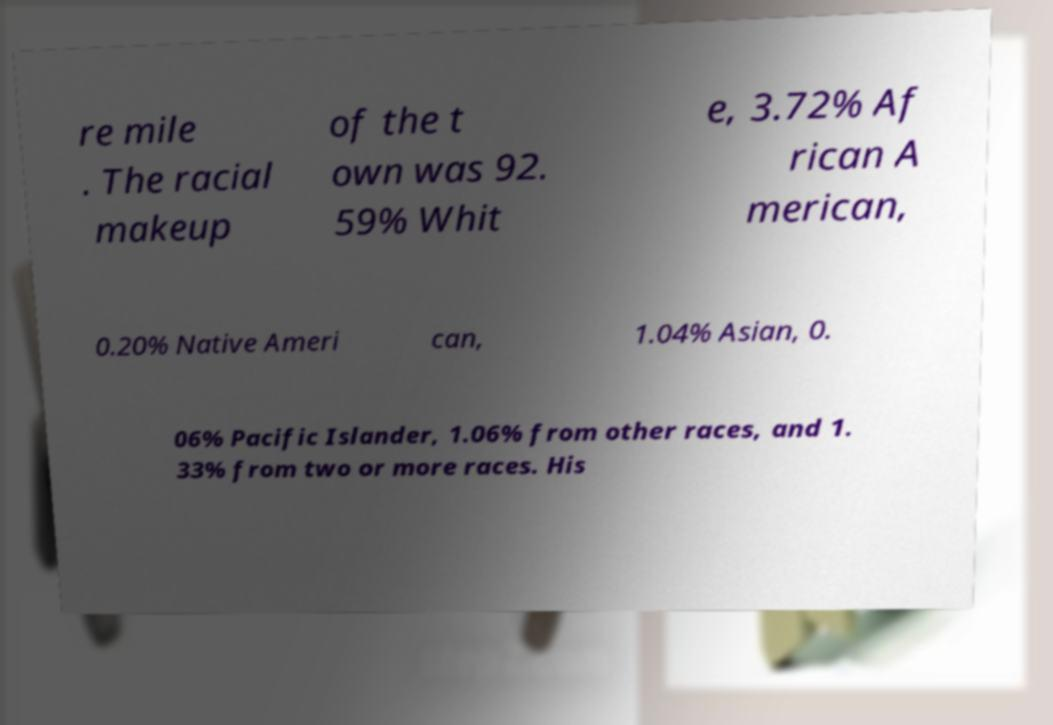I need the written content from this picture converted into text. Can you do that? re mile . The racial makeup of the t own was 92. 59% Whit e, 3.72% Af rican A merican, 0.20% Native Ameri can, 1.04% Asian, 0. 06% Pacific Islander, 1.06% from other races, and 1. 33% from two or more races. His 